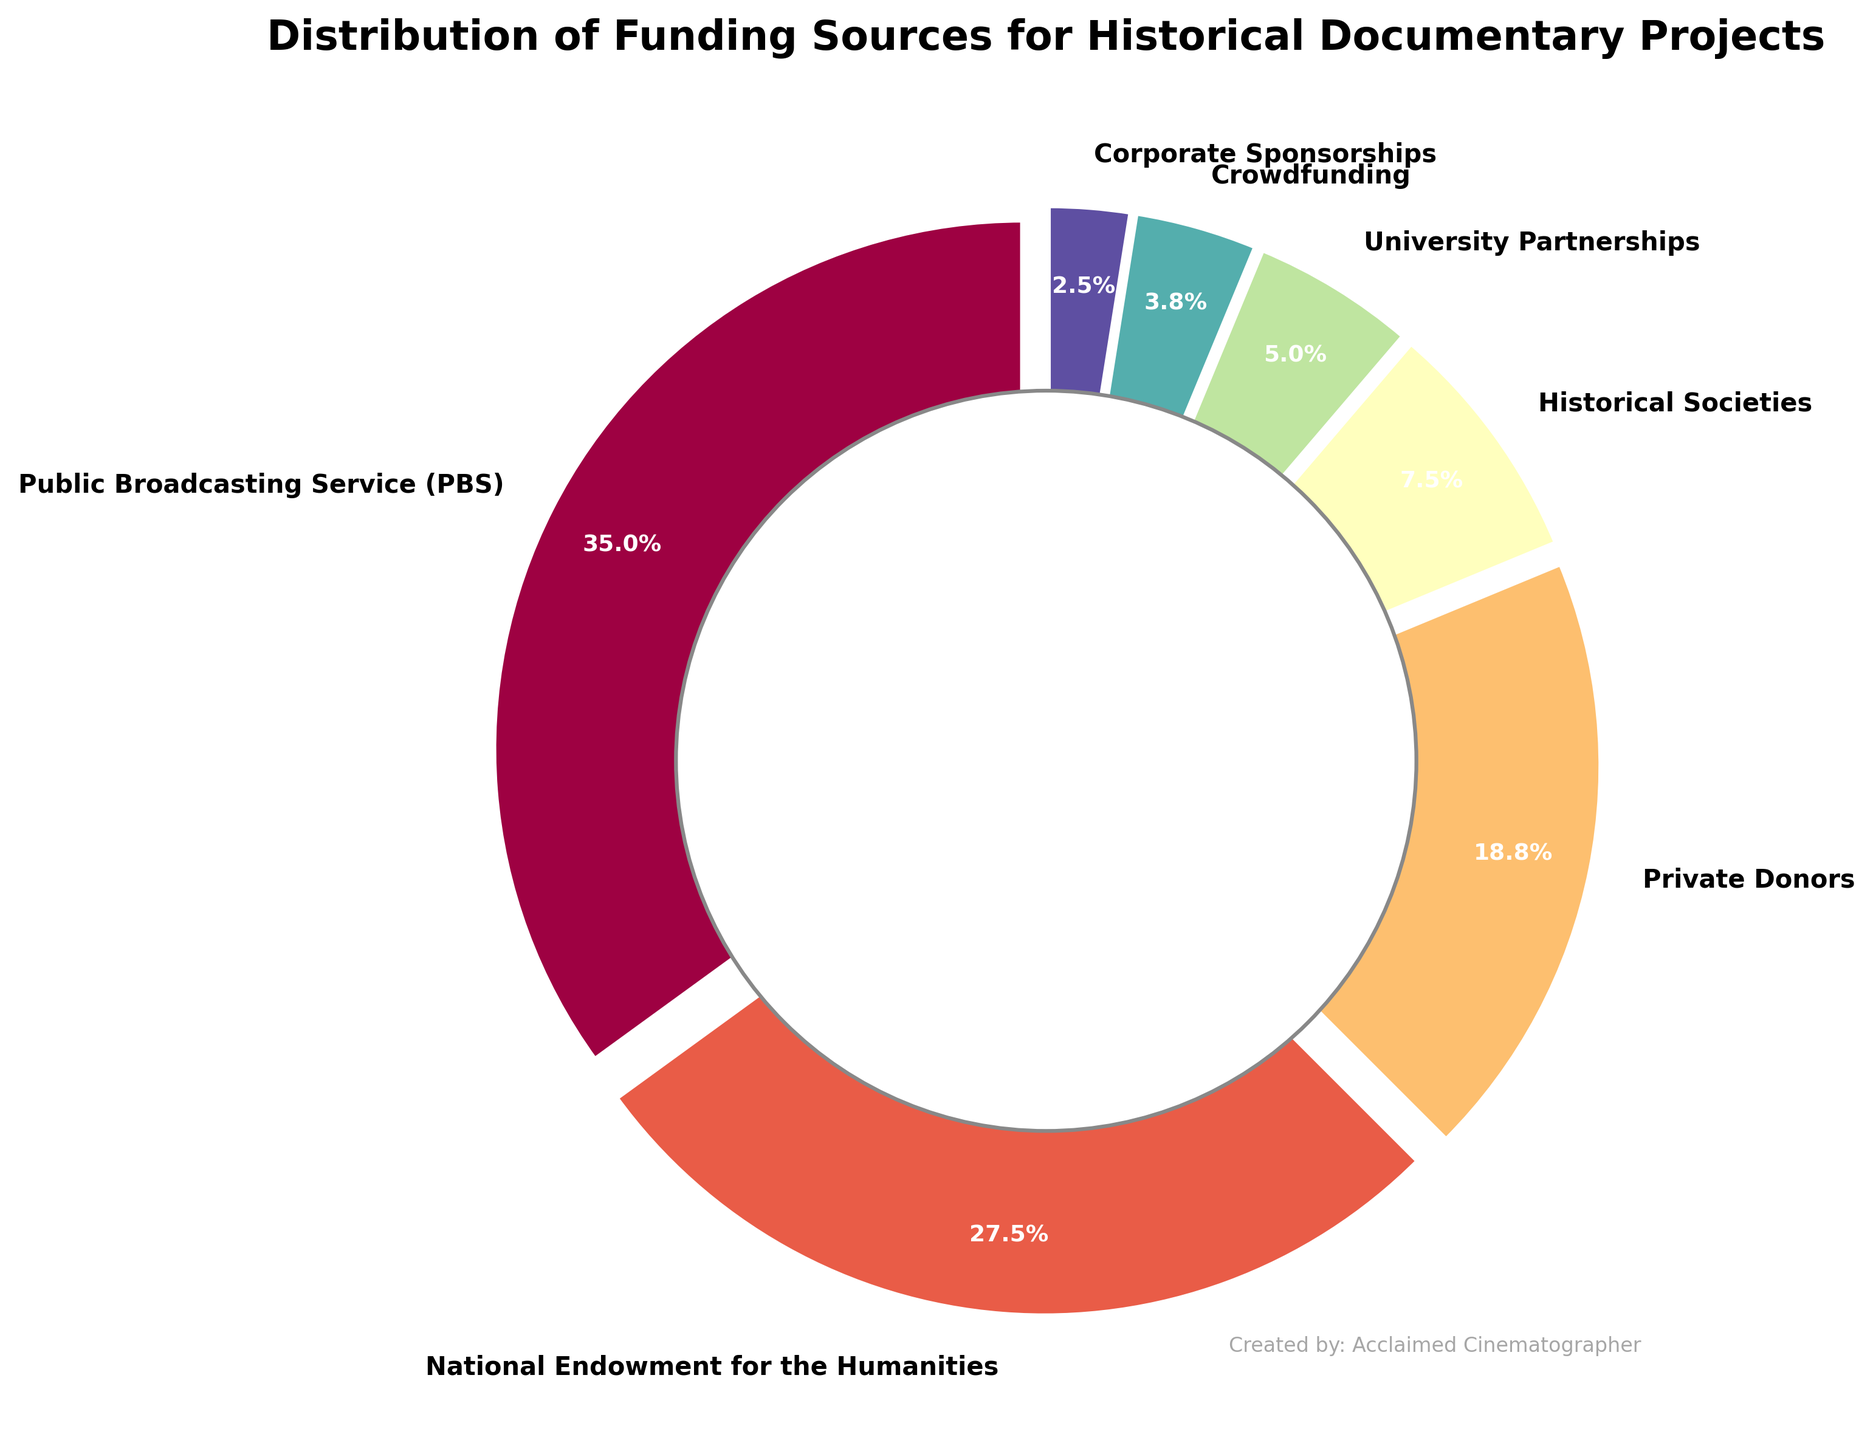What percentage of funding comes from private donors? The figure shows a pie chart with labels and their corresponding percentage values. Identify the section labeled "Private Donors" to find its percentage.
Answer: 15% Which funding source contributes the largest share? Analyze the pie chart to find the label with the highest percentage value.
Answer: Public Broadcasting Service (PBS) What is the combined percentage of funding from Historical Societies and University Partnerships? Locate the percentages for Historical Societies and University Partnerships on the pie chart, then sum these values: 6% (Historical Societies) + 4% (University Partnerships) = 10%.
Answer: 10% Is the percentage of funding from Crowdfunding greater or less than that from Corporate Sponsorships? Compare the percentages for Crowdfunding (3%) and Corporate Sponsorships (2%) shown in the pie chart.
Answer: Greater What color represents the funding from the National Endowment for the Humanities? Identify the color associated with the "National Endowment for the Humanities" label in the pie chart. Based on the color map, it should be one of the distinct hues used in the figure.
Answer: Orange (or specific color) How much more funding does PBS provide compared to Private Donors? Subtract the percentage of funding from Private Donors (15%) from the percentage of funding provided by PBS (28%): 28% - 15% = 13%.
Answer: 13% Which funding sources combined make up less than 10% of the total funding? Identify the funding sources with individual percentages less than 10%, then verify if their combination is less than 10%. University Partnerships (4%), Crowdfunding (3%), and Corporate Sponsorships (2%) can be summed: 4% + 3% + 2% = 9%.
Answer: University Partnerships, Crowdfunding, Corporate Sponsorships What's the percentage difference between the funding from the National Endowment for the Humanities and Historical Societies? Subtract the percentage of Historical Societies (6%) from the percentage of the National Endowment for the Humanities (22%): 22% - 6% = 16%.
Answer: 16% Rank the funding sources from highest to lowest percentage. Analyze the pie chart to list each funding source in order of their percentage values from highest to lowest: PBS (28%), National Endowment for the Humanities (22%), Private Donors (15%), Historical Societies (6%), University Partnerships (4%), Crowdfunding (3%), Corporate Sponsorships (2%).
Answer: PBS, National Endowment for the Humanities, Private Donors, Historical Societies, University Partnerships, Crowdfunding, Corporate Sponsorships 